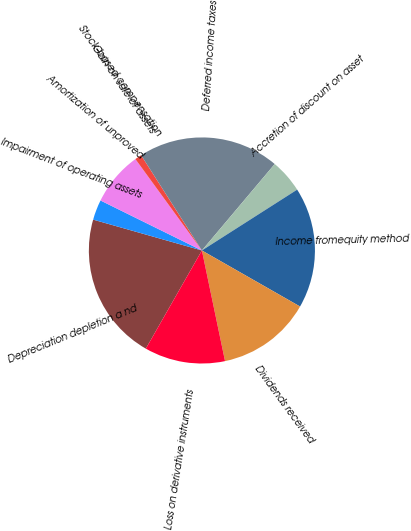<chart> <loc_0><loc_0><loc_500><loc_500><pie_chart><fcel>Depreciation depletion a nd<fcel>Impairment of operating assets<fcel>Amortization of unproved<fcel>Stock-based compensation<fcel>Gain on sale of assets<fcel>Deferred income taxes<fcel>Accretion of discount on asset<fcel>Income fromequity method<fcel>Dividends received<fcel>Loss on derivative instruments<nl><fcel>21.14%<fcel>2.89%<fcel>7.69%<fcel>0.01%<fcel>0.97%<fcel>20.18%<fcel>4.81%<fcel>17.3%<fcel>13.46%<fcel>11.54%<nl></chart> 